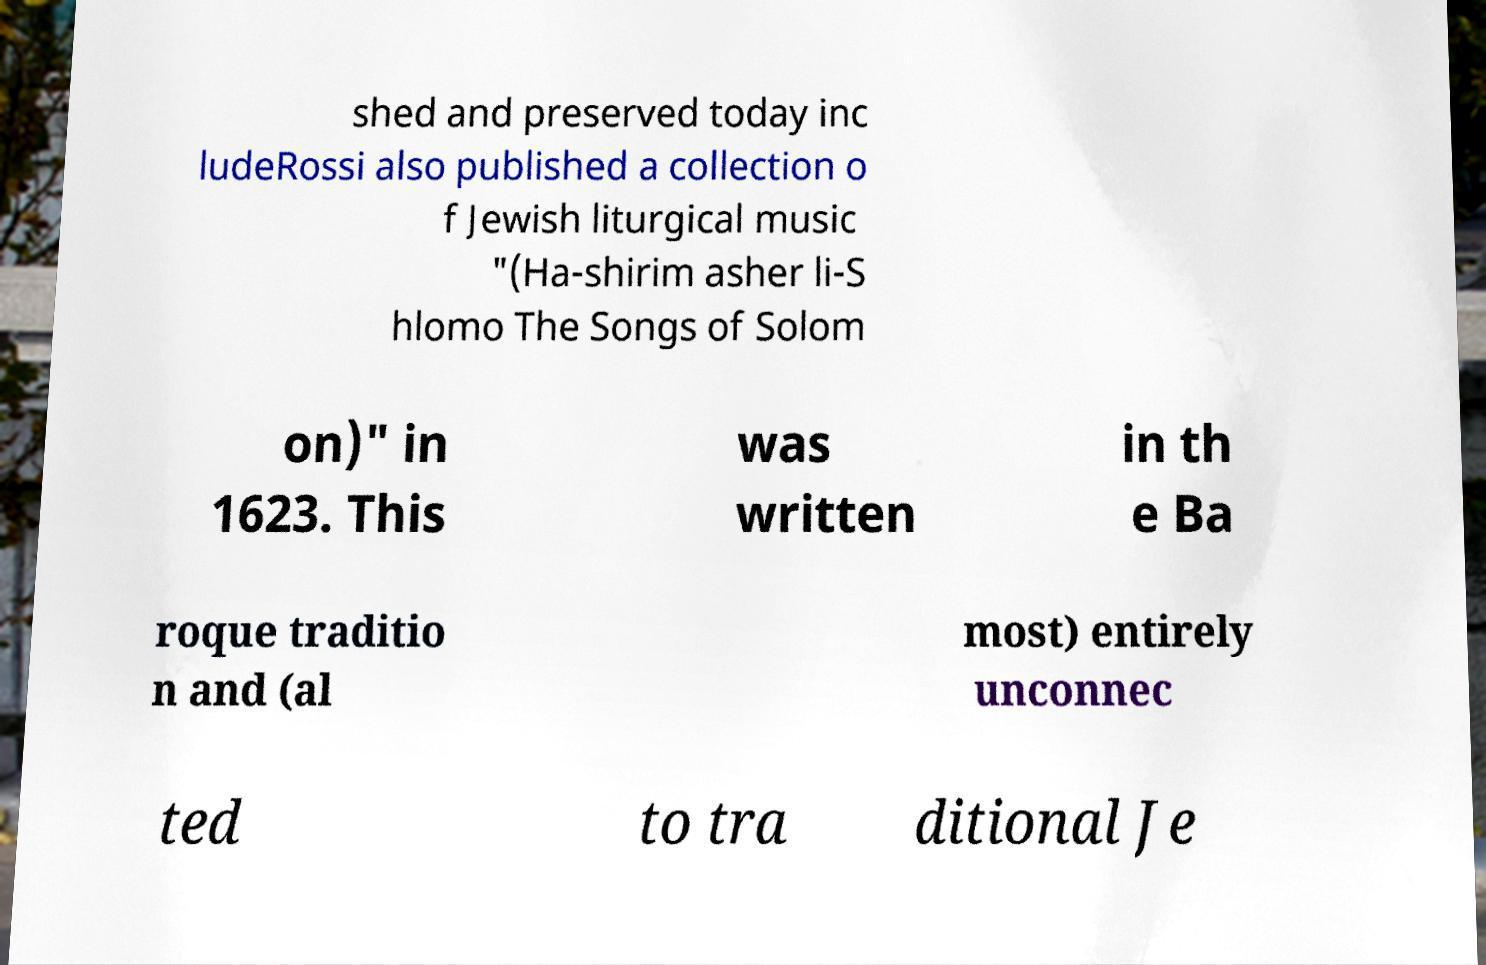Could you extract and type out the text from this image? shed and preserved today inc ludeRossi also published a collection o f Jewish liturgical music "(Ha-shirim asher li-S hlomo The Songs of Solom on)" in 1623. This was written in th e Ba roque traditio n and (al most) entirely unconnec ted to tra ditional Je 